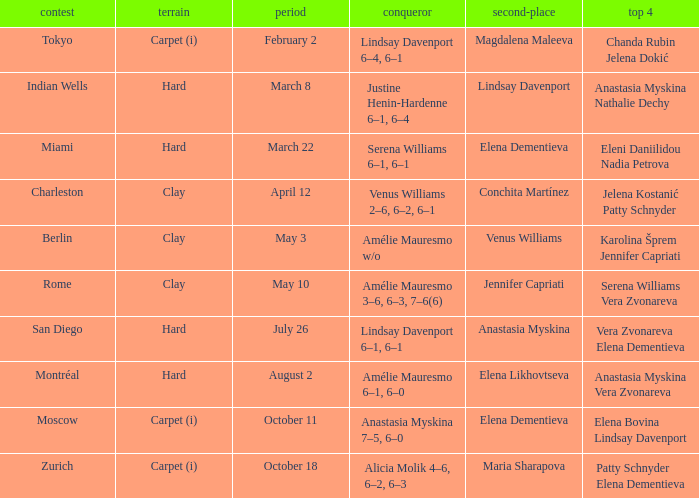Who was the finalist of the hard surface tournament in Miami? Elena Dementieva. 